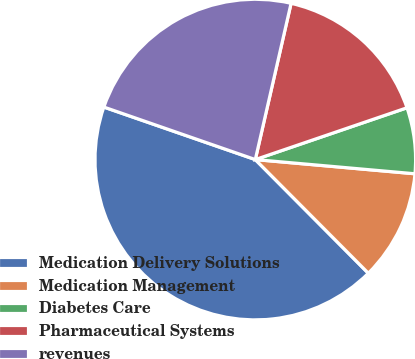<chart> <loc_0><loc_0><loc_500><loc_500><pie_chart><fcel>Medication Delivery Solutions<fcel>Medication Management<fcel>Diabetes Care<fcel>Pharmaceutical Systems<fcel>revenues<nl><fcel>42.77%<fcel>11.13%<fcel>6.65%<fcel>16.18%<fcel>23.27%<nl></chart> 